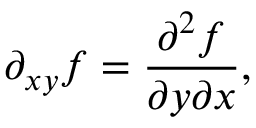<formula> <loc_0><loc_0><loc_500><loc_500>\partial _ { x y } f = { \frac { \partial ^ { 2 } f } { \partial y \partial x } } ,</formula> 